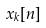<formula> <loc_0><loc_0><loc_500><loc_500>x _ { k } [ n ]</formula> 